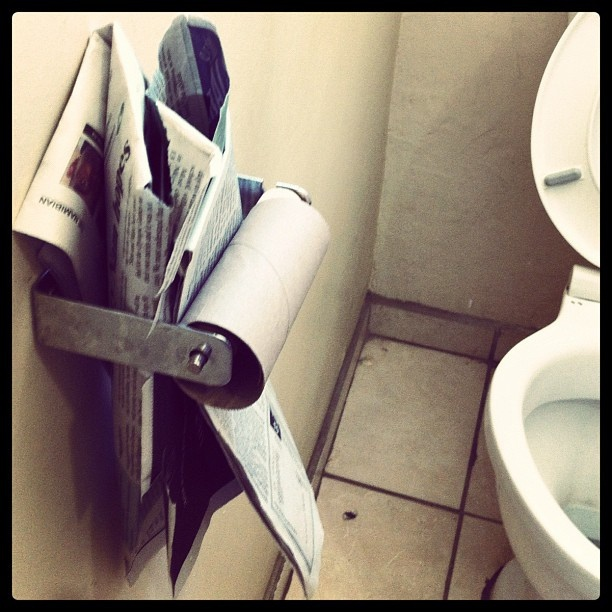Describe the objects in this image and their specific colors. I can see a toilet in black, ivory, beige, darkgray, and gray tones in this image. 